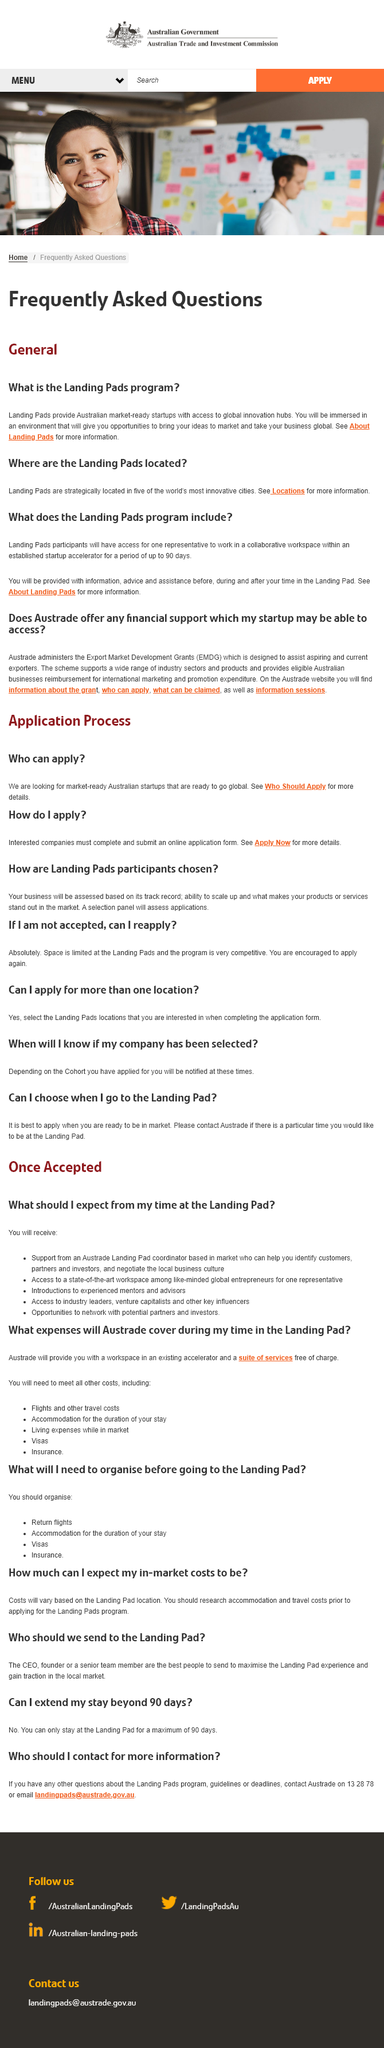Specify some key components in this picture. I, [Your Name], hereby declare that I will be immersed into an environment that will provide me with opportunities and access to a collaborative workspace. The number of cities with Landing pads is five. Landing pad participants will have access to one representative. 